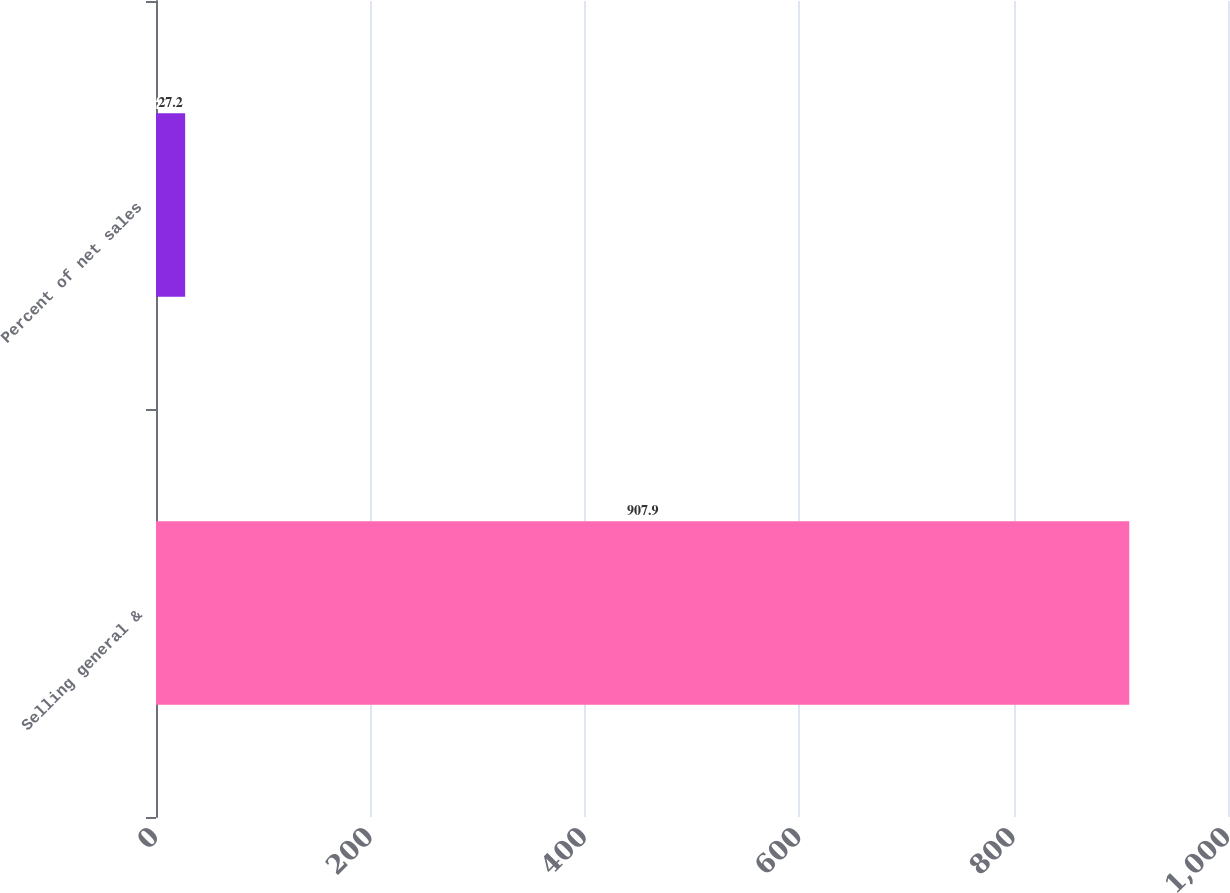Convert chart to OTSL. <chart><loc_0><loc_0><loc_500><loc_500><bar_chart><fcel>Selling general &<fcel>Percent of net sales<nl><fcel>907.9<fcel>27.2<nl></chart> 